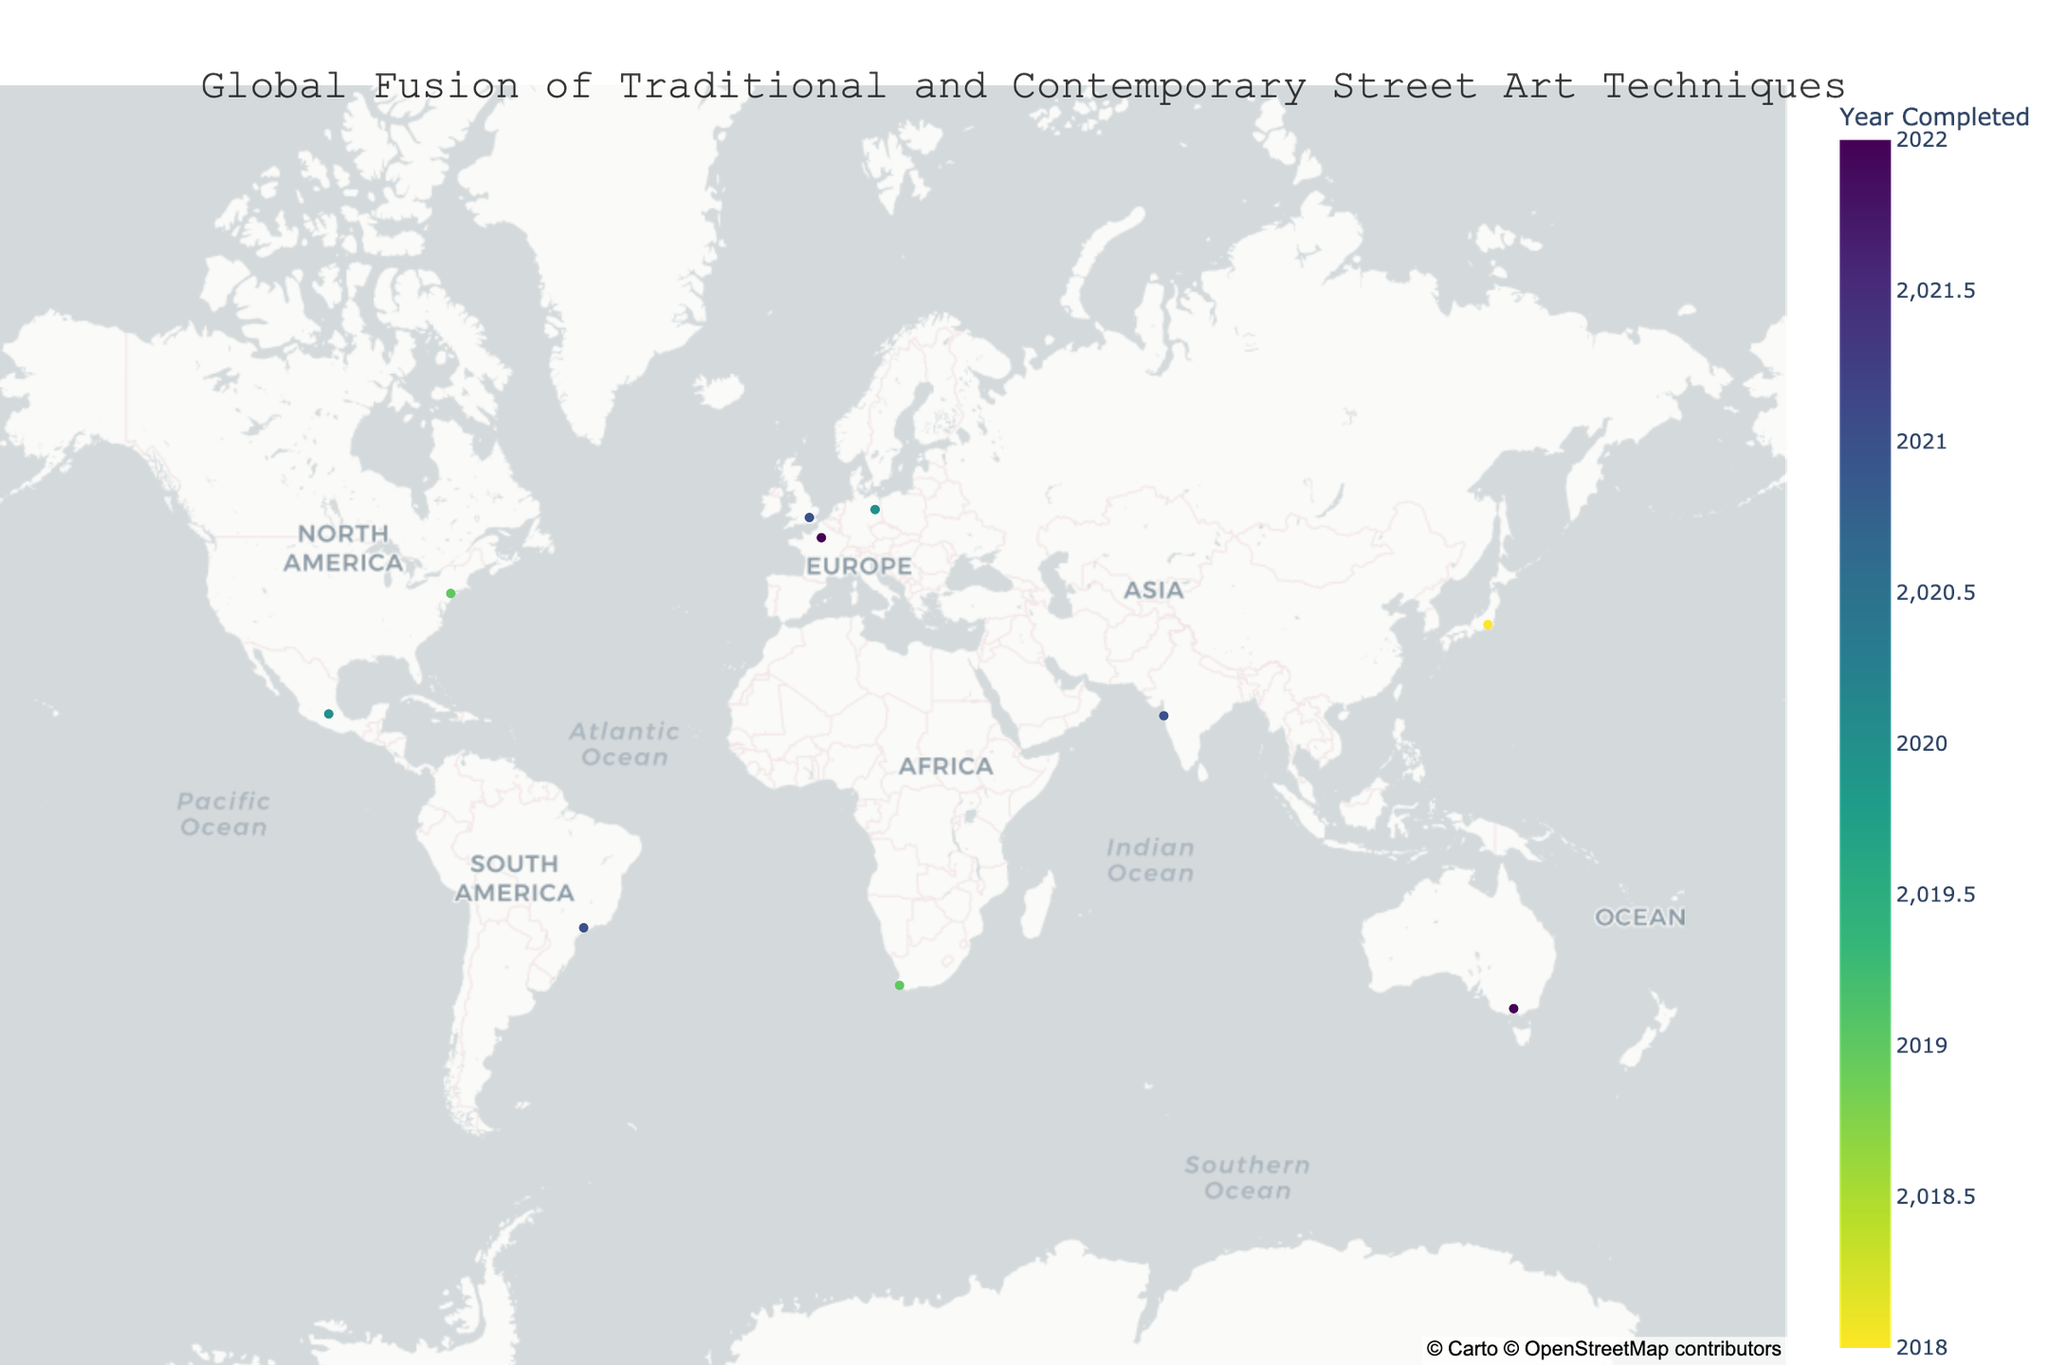How many street art and mural projects are shown on the map? The map includes specific data points for each street art and mural project displayed globally. By counting these data points, we determine the total number of projects visualized.
Answer: 10 Which city features a project completed in the earliest year on the map? By examining the 'Year Completed' values for all projects displayed on the map, we identify the earliest year and locate the corresponding city.
Answer: Tokyo (2018) Which contemporary technique is used in the Berlin project's mural? By locating the Berlin project on the map and referring to its hover information, we identify the contemporary technique employed.
Answer: LED Installation What is the average year of completion for all the projects displayed? First, sum up the years of all projects. Then, divide this sum by the total number of projects to get the average completion year. Sum = 2019 + 2021 + 2020 + 2022 + 2018 + 2021 + 2020 + 2019 + 2022 + 2021 = 20223. Divide by 10 projects = 20223 / 10 = 2020.3.
Answer: 2020.3 How many projects utilize digital forms of contemporary techniques, such as Augmented Reality, Video Mapping, or Interactive Sensors? By identifying and counting the projects that mention digital techniques (e.g., Augmented Reality, Video Mapping, Interactive Sensors) in their hover information, we can determine the total number employing these methods.
Answer: 3 Which city has combined traditional Calligraphy with Neon Lighting in its mural project? By examining the hover information for each project's contemporary and traditional techniques, we identify the city that has combined Calligraphy and Neon Lighting.
Answer: London Which project uses the combination of Stencil Art and Augmented Reality, and in which city is it located? By checking the hover information for each mural project, we identify the project and city that employ the techniques of Stencil Art and Augmented Reality.
Answer: Hosier Lane Project, Melbourne What is the latest year in which one of the street art projects was completed, and which cities have projects completed in that year? By checking the 'Year Completed' values for all projects and identifying the latest year, we then locate the corresponding cities.
Answer: 2022; Melbourne and Paris 